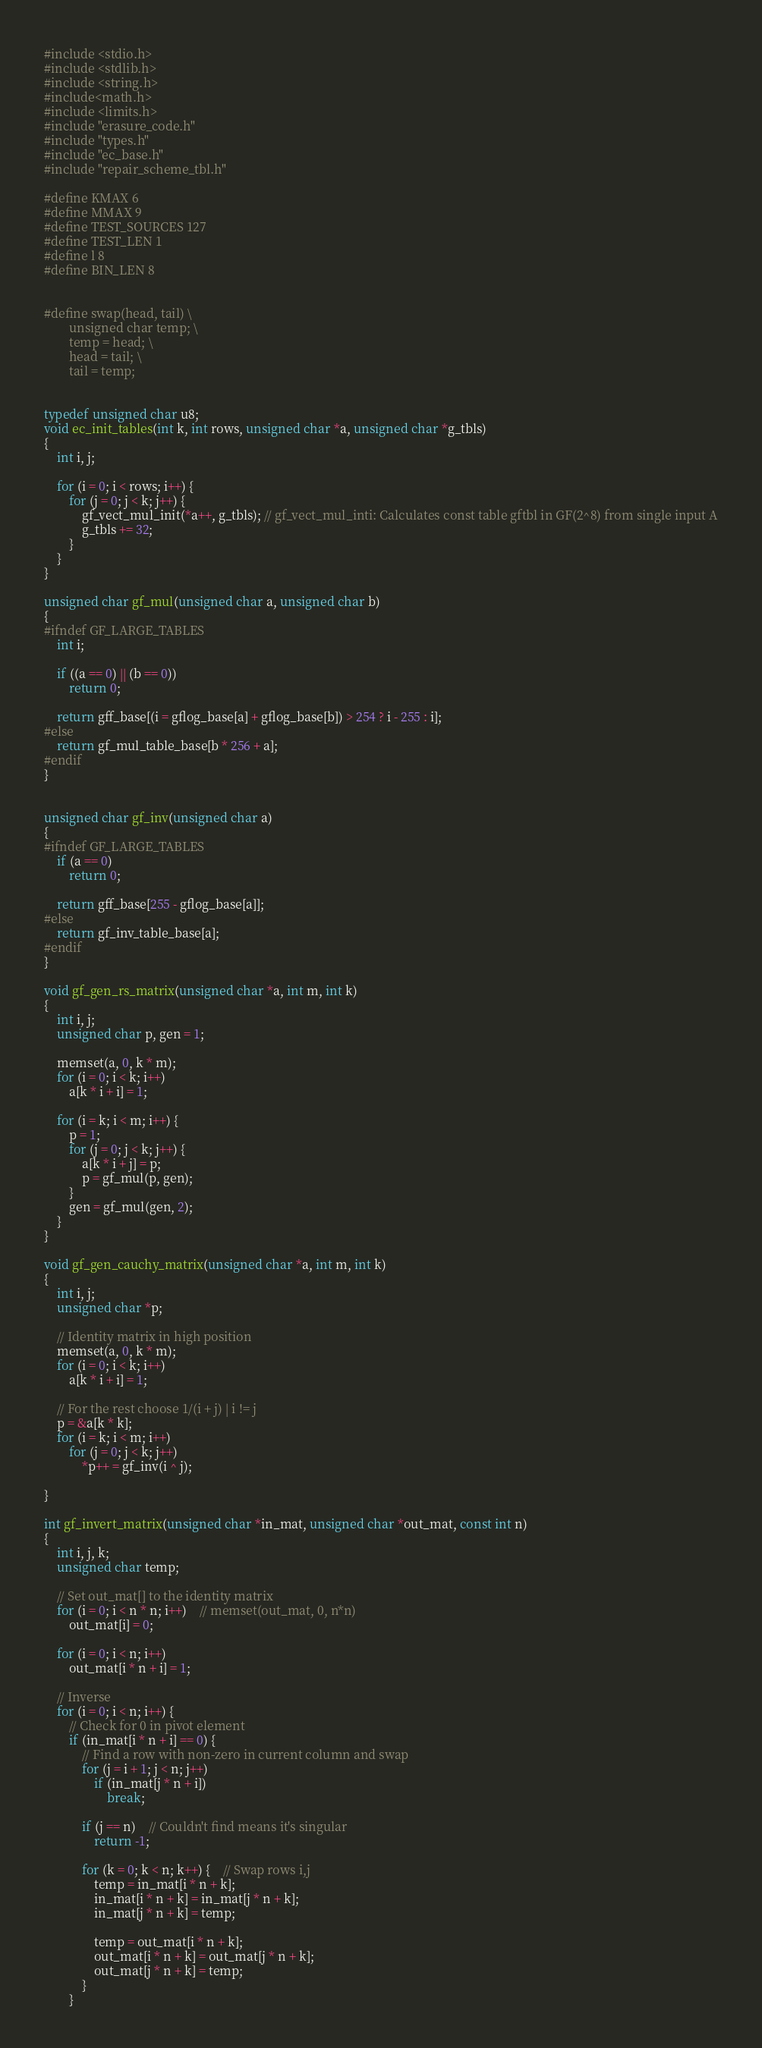<code> <loc_0><loc_0><loc_500><loc_500><_C_>#include <stdio.h>
#include <stdlib.h>
#include <string.h>	
#include<math.h>
#include <limits.h>	
#include "erasure_code.h"
#include "types.h"
#include "ec_base.h"
#include "repair_scheme_tbl.h"

#define KMAX 6
#define MMAX 9
#define TEST_SOURCES 127
#define TEST_LEN 1
#define l 8
#define BIN_LEN 8


#define swap(head, tail) \
		unsigned char temp; \
		temp = head; \
		head = tail; \
		tail = temp;	


typedef unsigned char u8;
void ec_init_tables(int k, int rows, unsigned char *a, unsigned char *g_tbls)
{
	int i, j;

	for (i = 0; i < rows; i++) {
		for (j = 0; j < k; j++) {
			gf_vect_mul_init(*a++, g_tbls); // gf_vect_mul_inti: Calculates const table gftbl in GF(2^8) from single input A
			g_tbls += 32;
		}
	}
}

unsigned char gf_mul(unsigned char a, unsigned char b)
{
#ifndef GF_LARGE_TABLES
	int i;

	if ((a == 0) || (b == 0))
		return 0;

	return gff_base[(i = gflog_base[a] + gflog_base[b]) > 254 ? i - 255 : i];
#else
	return gf_mul_table_base[b * 256 + a];
#endif
}


unsigned char gf_inv(unsigned char a)
{
#ifndef GF_LARGE_TABLES
	if (a == 0)
		return 0;

	return gff_base[255 - gflog_base[a]];
#else
	return gf_inv_table_base[a];
#endif
}

void gf_gen_rs_matrix(unsigned char *a, int m, int k)
{
	int i, j;
	unsigned char p, gen = 1;

	memset(a, 0, k * m);
	for (i = 0; i < k; i++)
		a[k * i + i] = 1;

	for (i = k; i < m; i++) {
		p = 1;
		for (j = 0; j < k; j++) {
			a[k * i + j] = p;
			p = gf_mul(p, gen);
		}
		gen = gf_mul(gen, 2);
	}
}

void gf_gen_cauchy_matrix(unsigned char *a, int m, int k)
{
	int i, j;
	unsigned char *p;

	// Identity matrix in high position
	memset(a, 0, k * m);
	for (i = 0; i < k; i++)
		a[k * i + i] = 1;

	// For the rest choose 1/(i + j) | i != j
	p = &a[k * k];
	for (i = k; i < m; i++)
		for (j = 0; j < k; j++)
			*p++ = gf_inv(i ^ j);

}

int gf_invert_matrix(unsigned char *in_mat, unsigned char *out_mat, const int n)
{
	int i, j, k;
	unsigned char temp;

	// Set out_mat[] to the identity matrix
	for (i = 0; i < n * n; i++)	// memset(out_mat, 0, n*n)
		out_mat[i] = 0;

	for (i = 0; i < n; i++)
		out_mat[i * n + i] = 1;

	// Inverse
	for (i = 0; i < n; i++) {
		// Check for 0 in pivot element
		if (in_mat[i * n + i] == 0) {
			// Find a row with non-zero in current column and swap
			for (j = i + 1; j < n; j++)
				if (in_mat[j * n + i])
					break;

			if (j == n)	// Couldn't find means it's singular
				return -1;

			for (k = 0; k < n; k++) {	// Swap rows i,j
				temp = in_mat[i * n + k];
				in_mat[i * n + k] = in_mat[j * n + k];
				in_mat[j * n + k] = temp;

				temp = out_mat[i * n + k];
				out_mat[i * n + k] = out_mat[j * n + k];
				out_mat[j * n + k] = temp;
			}
		}
</code> 